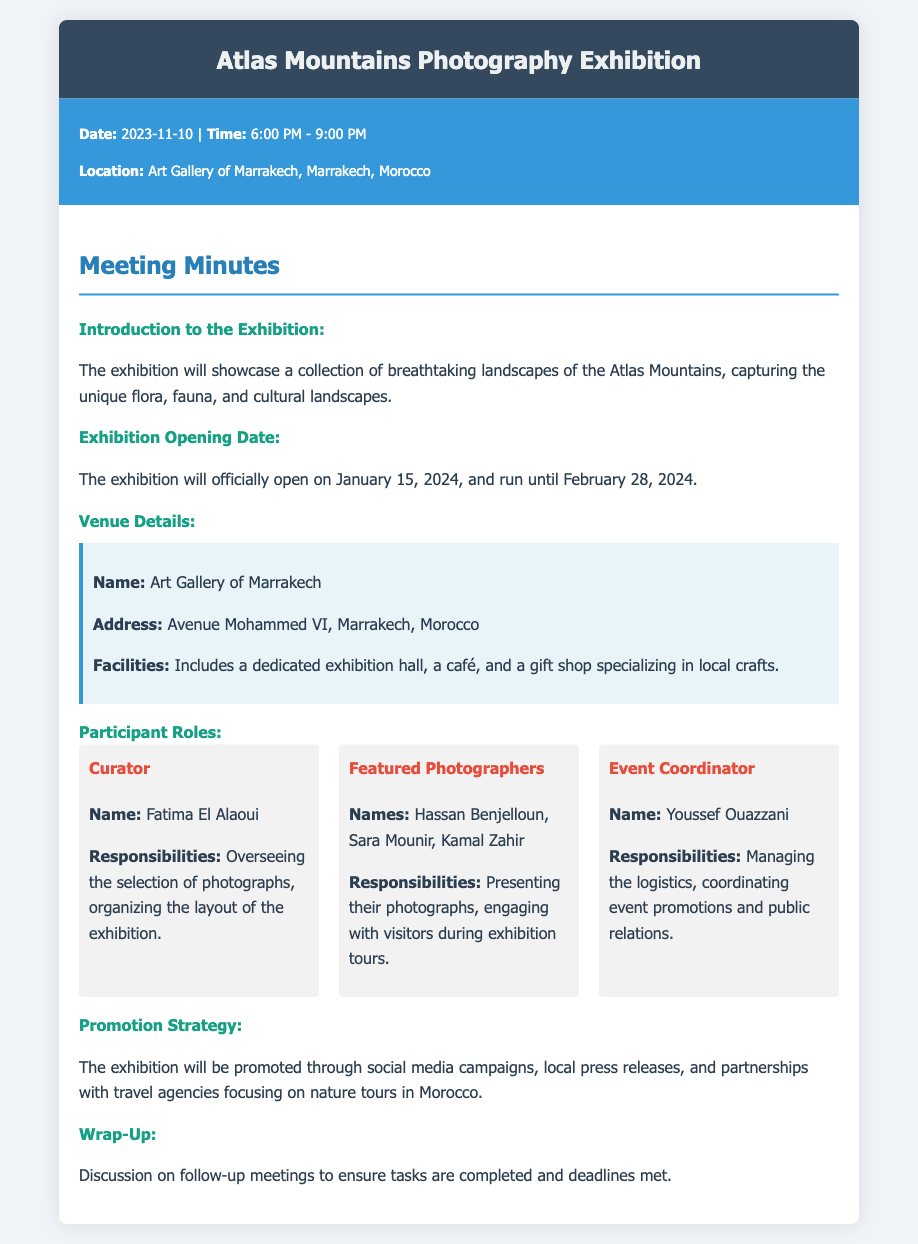what is the opening date of the exhibition? The opening date is specified in the document as January 15, 2024.
Answer: January 15, 2024 where is the exhibition located? The document mentions the location as Art Gallery of Marrakech, Marrakech, Morocco.
Answer: Art Gallery of Marrakech, Marrakech, Morocco who is the event coordinator? The document lists the event coordinator's name as Youssef Ouazzani.
Answer: Youssef Ouazzani what type of promotion strategy will be used? The promotion strategy includes social media campaigns and local press releases, as stated in the document.
Answer: Social media campaigns, local press releases how long will the exhibition run? The document specifies that the exhibition will run until February 28, 2024, indicating it will be open for a certain duration.
Answer: Until February 28, 2024 what is the main focus of the photographs in the exhibition? The meeting minutes detail that the photographs will focus on breathtaking landscapes of the Atlas Mountains.
Answer: Breathtaking landscapes of the Atlas Mountains who oversees the selection of photographs? The curator's responsibility for overseeing the selection of photographs is mentioned in the document.
Answer: Fatima El Alaoui what facilities are available at the venue? The document outlines the facilities as including a dedicated exhibition hall, a café, and a gift shop specializing in local crafts.
Answer: Dedicated exhibition hall, café, gift shop 